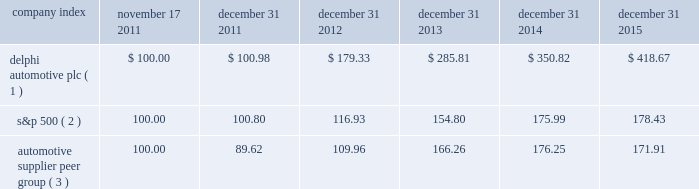Table of contents stock performance graph * $ 100 invested on 11/17/11 in our stock or 10/31/11 in the relevant index , including reinvestment of dividends .
Fiscal year ending december 31 , 2015 .
( 1 ) delphi automotive plc ( 2 ) s&p 500 2013 standard & poor 2019s 500 total return index ( 3 ) automotive supplier peer group 2013 russell 3000 auto parts index , including american axle & manufacturing , borgwarner inc. , cooper tire & rubber company , dana holding corp. , delphi automotive plc , dorman products inc. , federal-mogul corp. , ford motor co. , fuel systems solutions inc. , general motors co. , gentex corp. , gentherm inc. , genuine parts co. , johnson controls inc. , lear corp. , lkq corp. , meritor inc. , standard motor products inc. , stoneridge inc. , superior industries international , tenneco inc. , tesla motors inc. , the goodyear tire & rubber co. , tower international inc. , visteon corp. , and wabco holdings inc .
Company index november 17 , december 31 , december 31 , december 31 , december 31 , december 31 .
Dividends the company has declared and paid cash dividends of $ 0.25 per ordinary share in each quarter of 2014 and 2015 .
In addition , in january 2016 , the board of directors increased the annual dividend rate to $ 1.16 per ordinary share , and declared a regular quarterly cash dividend of $ 0.29 per ordinary share , payable on february 29 , 2016 to shareholders of record at the close of business on february 17 , 2016. .
What is the total return on delphi automotive plc for the five year period ending december 31 2015? 
Computations: ((418.67 - 100) / 100)
Answer: 3.1867. Table of contents stock performance graph * $ 100 invested on 11/17/11 in our stock or 10/31/11 in the relevant index , including reinvestment of dividends .
Fiscal year ending december 31 , 2015 .
( 1 ) delphi automotive plc ( 2 ) s&p 500 2013 standard & poor 2019s 500 total return index ( 3 ) automotive supplier peer group 2013 russell 3000 auto parts index , including american axle & manufacturing , borgwarner inc. , cooper tire & rubber company , dana holding corp. , delphi automotive plc , dorman products inc. , federal-mogul corp. , ford motor co. , fuel systems solutions inc. , general motors co. , gentex corp. , gentherm inc. , genuine parts co. , johnson controls inc. , lear corp. , lkq corp. , meritor inc. , standard motor products inc. , stoneridge inc. , superior industries international , tenneco inc. , tesla motors inc. , the goodyear tire & rubber co. , tower international inc. , visteon corp. , and wabco holdings inc .
Company index november 17 , december 31 , december 31 , december 31 , december 31 , december 31 .
Dividends the company has declared and paid cash dividends of $ 0.25 per ordinary share in each quarter of 2014 and 2015 .
In addition , in january 2016 , the board of directors increased the annual dividend rate to $ 1.16 per ordinary share , and declared a regular quarterly cash dividend of $ 0.29 per ordinary share , payable on february 29 , 2016 to shareholders of record at the close of business on february 17 , 2016. .
What is the lowest return for the last year of the investment? 
Rationale: it is the minimum value turned into a percentage .
Computations: (171.91 - 100)
Answer: 71.91. 